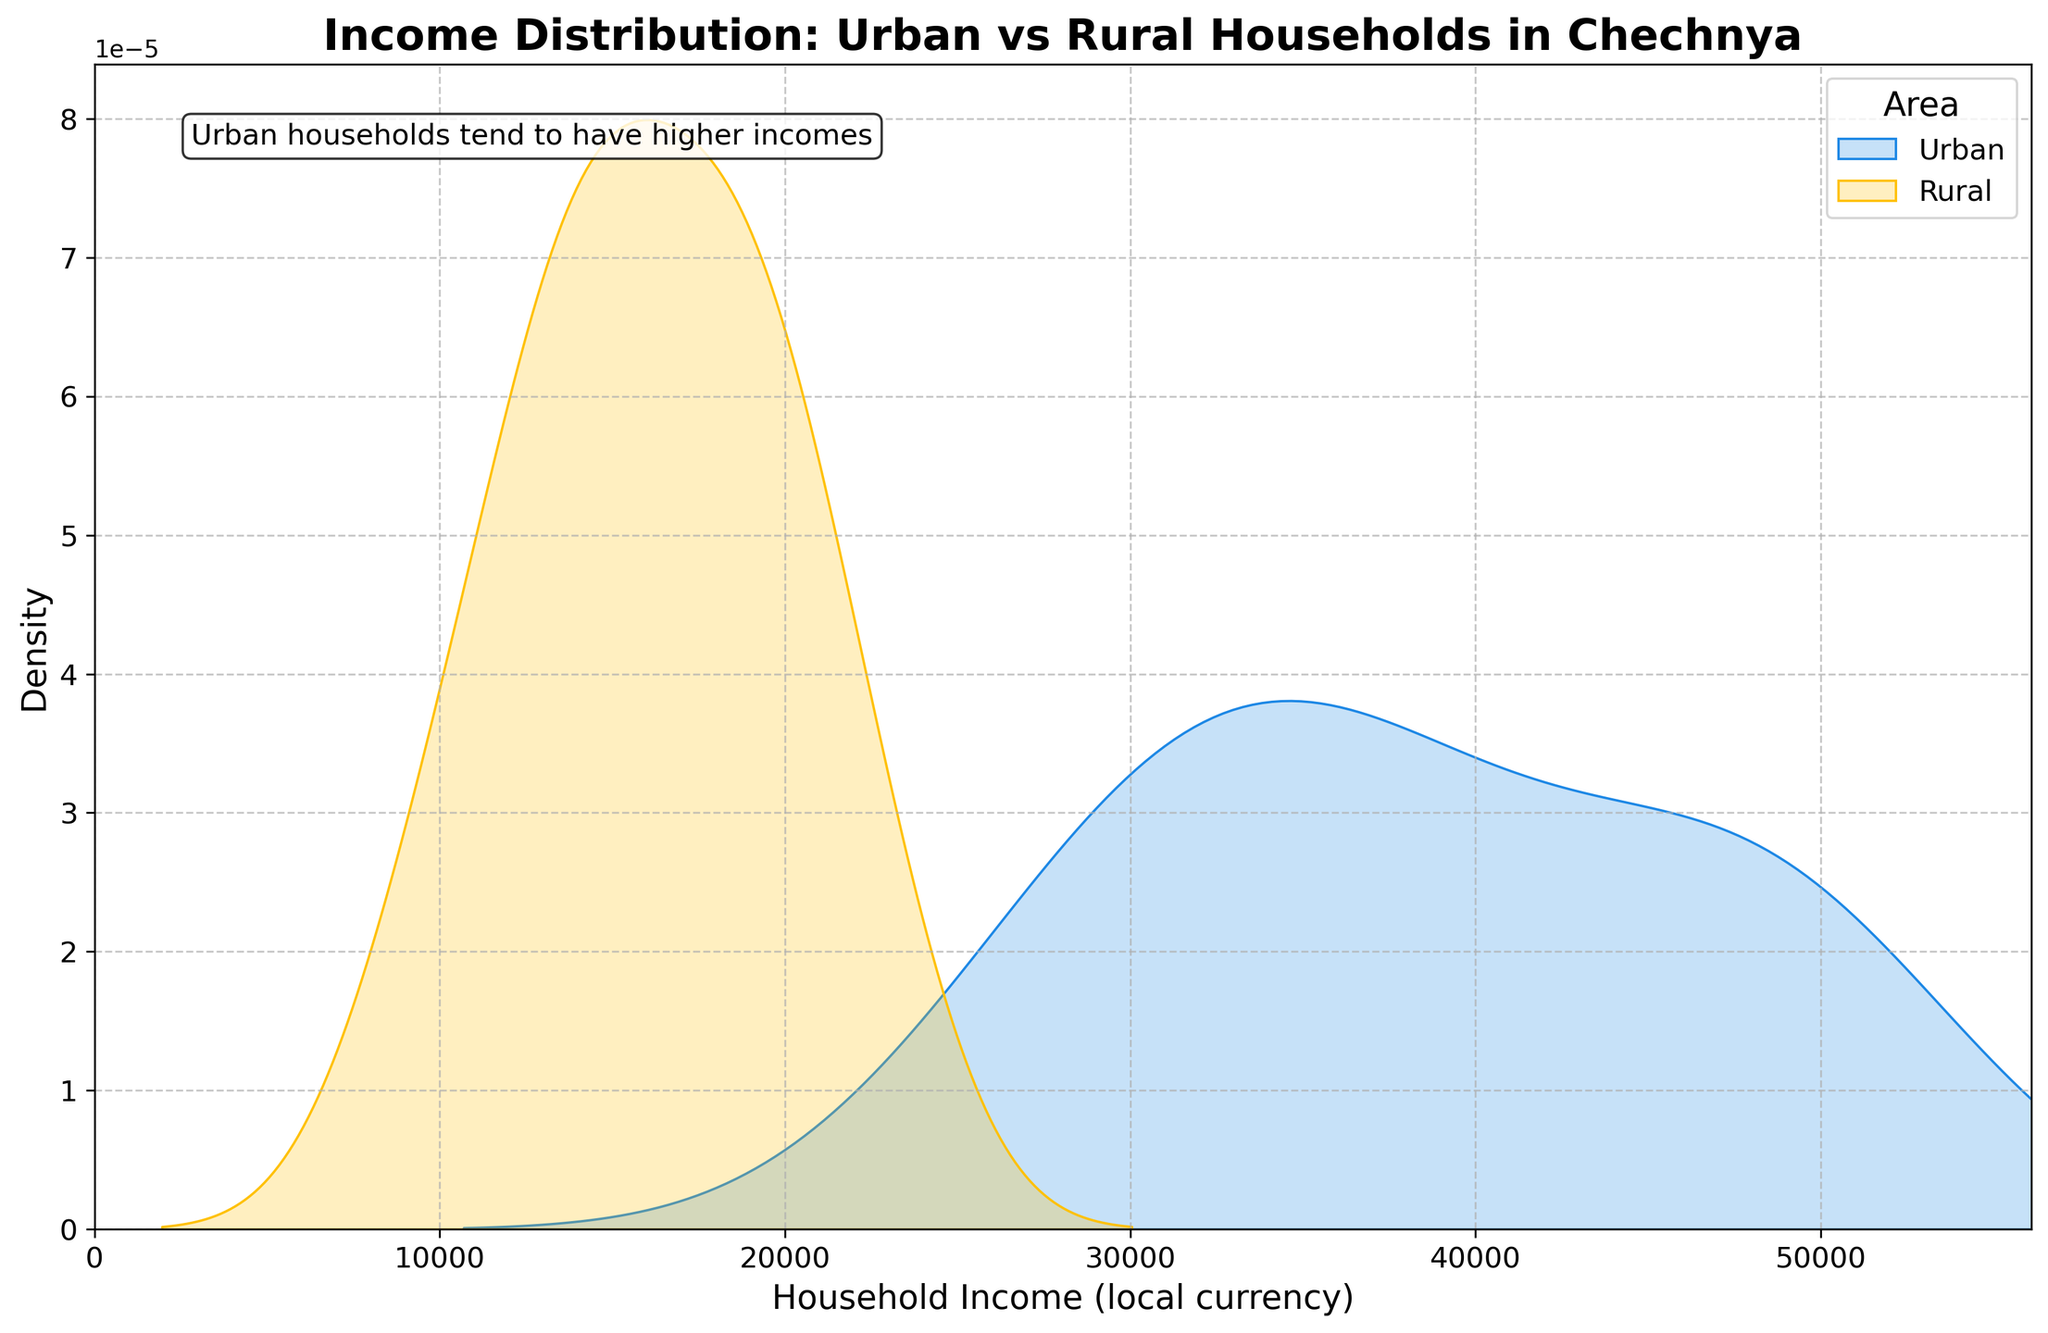What is the title of the plot? The title is displayed at the top of the plot. It shows "Income Distribution: Urban vs Rural Households in Chechnya".
Answer: Income Distribution: Urban vs Rural Households in Chechnya What colors represent urban and rural areas in the plot? In the plot, urban areas are represented in blue while rural areas are represented in yellow. This is also indicated in the legend on the plot.
Answer: Blue for urban, yellow for rural Which area tends to have higher household incomes, urban or rural? The plot shows two distributions, and the distribution for urban households (blue) is shifted to higher income values compared to rural households (yellow).
Answer: Urban What is the general shape of the income distribution for urban households? The distribution for urban households (blue) appears to be unimodal and somewhat symmetric, with a peak value around 35,000 to 45,000.
Answer: Unimodal and symmetric What is the general shape of the income distribution for rural households? The distribution for rural households (yellow) appears to be also unimodal but more skewed to the right, with a peak value around 12,000 to 20,000.
Answer: Unimodal and right-skewed What is the approximate range of household incomes for urban areas? By looking at the horizontal axis of the plot, the income values for urban households roughly range between 26,500 and 51,000.
Answer: 26,500 to 51,000 What is the approximate range of household incomes for rural areas? The plot shows that the income for rural households ranges roughly between 9,500 and 22,500.
Answer: 9,500 to 22,500 Which area has a denser income distribution around its peak value? The plot density peaks are higher for the urban area (blue) indicating a denser distribution around their peak value compared to the rural area (yellow).
Answer: Urban Approximately, what is the median household income for urban areas as seen in the plot? The median household income can be estimated by finding the middle value of the urban density curve, which peaks around 35,000 to 45,000, suggesting a median near these values.
Answer: About 35,000 to 45,000 How does the skewness of household income differ between urban and rural areas? Urban household income distribution appears more symmetric, while rural household income distribution is skewed to the right, indicating many lower-income households and fewer high-income ones.
Answer: Urban: Symmetric, Rural: Right-skewed 